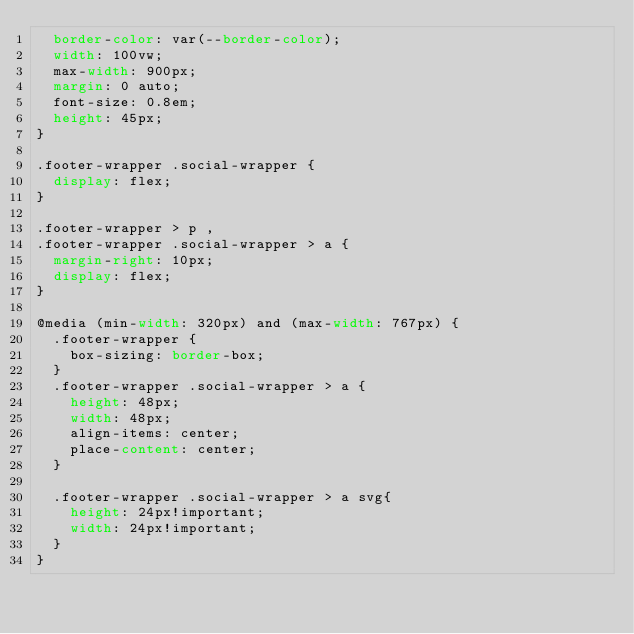Convert code to text. <code><loc_0><loc_0><loc_500><loc_500><_CSS_>  border-color: var(--border-color);
  width: 100vw;
  max-width: 900px;
  margin: 0 auto;
  font-size: 0.8em;
  height: 45px;
}

.footer-wrapper .social-wrapper {
  display: flex;
}

.footer-wrapper > p ,
.footer-wrapper .social-wrapper > a {
  margin-right: 10px;
  display: flex;
}

@media (min-width: 320px) and (max-width: 767px) {
  .footer-wrapper {
    box-sizing: border-box;
  }
  .footer-wrapper .social-wrapper > a {
    height: 48px;
    width: 48px;
    align-items: center;
    place-content: center;
  }

  .footer-wrapper .social-wrapper > a svg{
    height: 24px!important;
    width: 24px!important;
  }
}</code> 